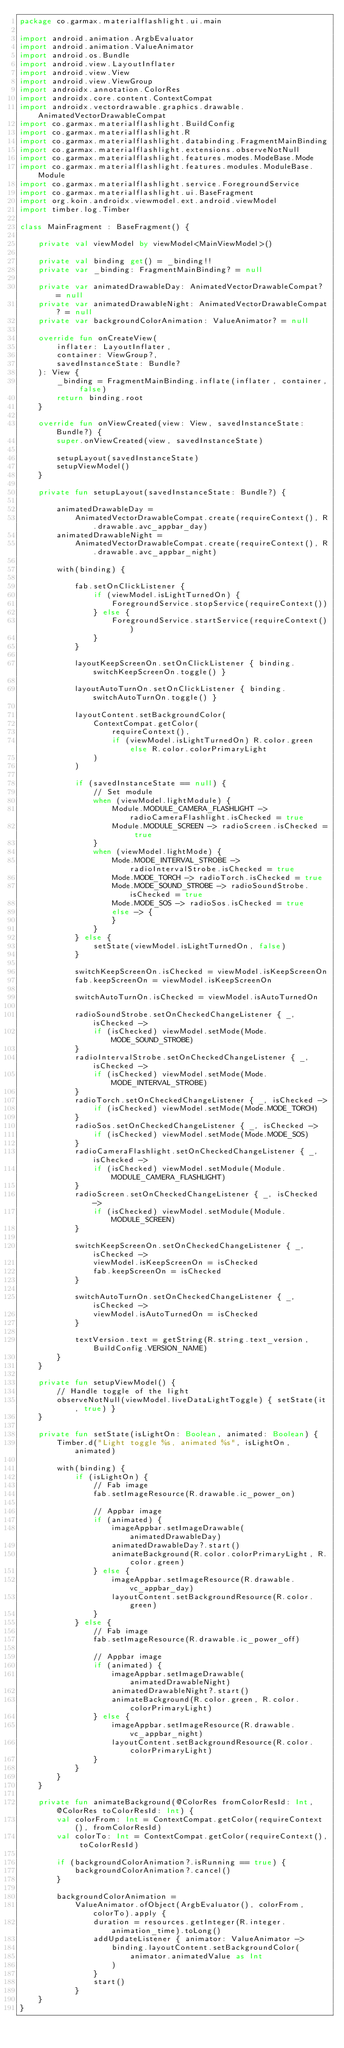<code> <loc_0><loc_0><loc_500><loc_500><_Kotlin_>package co.garmax.materialflashlight.ui.main

import android.animation.ArgbEvaluator
import android.animation.ValueAnimator
import android.os.Bundle
import android.view.LayoutInflater
import android.view.View
import android.view.ViewGroup
import androidx.annotation.ColorRes
import androidx.core.content.ContextCompat
import androidx.vectordrawable.graphics.drawable.AnimatedVectorDrawableCompat
import co.garmax.materialflashlight.BuildConfig
import co.garmax.materialflashlight.R
import co.garmax.materialflashlight.databinding.FragmentMainBinding
import co.garmax.materialflashlight.extensions.observeNotNull
import co.garmax.materialflashlight.features.modes.ModeBase.Mode
import co.garmax.materialflashlight.features.modules.ModuleBase.Module
import co.garmax.materialflashlight.service.ForegroundService
import co.garmax.materialflashlight.ui.BaseFragment
import org.koin.androidx.viewmodel.ext.android.viewModel
import timber.log.Timber

class MainFragment : BaseFragment() {

    private val viewModel by viewModel<MainViewModel>()

    private val binding get() = _binding!!
    private var _binding: FragmentMainBinding? = null

    private var animatedDrawableDay: AnimatedVectorDrawableCompat? = null
    private var animatedDrawableNight: AnimatedVectorDrawableCompat? = null
    private var backgroundColorAnimation: ValueAnimator? = null

    override fun onCreateView(
        inflater: LayoutInflater,
        container: ViewGroup?,
        savedInstanceState: Bundle?
    ): View {
        _binding = FragmentMainBinding.inflate(inflater, container, false)
        return binding.root
    }

    override fun onViewCreated(view: View, savedInstanceState: Bundle?) {
        super.onViewCreated(view, savedInstanceState)

        setupLayout(savedInstanceState)
        setupViewModel()
    }

    private fun setupLayout(savedInstanceState: Bundle?) {

        animatedDrawableDay =
            AnimatedVectorDrawableCompat.create(requireContext(), R.drawable.avc_appbar_day)
        animatedDrawableNight =
            AnimatedVectorDrawableCompat.create(requireContext(), R.drawable.avc_appbar_night)

        with(binding) {

            fab.setOnClickListener {
                if (viewModel.isLightTurnedOn) {
                    ForegroundService.stopService(requireContext())
                } else {
                    ForegroundService.startService(requireContext())
                }
            }

            layoutKeepScreenOn.setOnClickListener { binding.switchKeepScreenOn.toggle() }

            layoutAutoTurnOn.setOnClickListener { binding.switchAutoTurnOn.toggle() }

            layoutContent.setBackgroundColor(
                ContextCompat.getColor(
                    requireContext(),
                    if (viewModel.isLightTurnedOn) R.color.green else R.color.colorPrimaryLight
                )
            )

            if (savedInstanceState == null) {
                // Set module
                when (viewModel.lightModule) {
                    Module.MODULE_CAMERA_FLASHLIGHT -> radioCameraFlashlight.isChecked = true
                    Module.MODULE_SCREEN -> radioScreen.isChecked = true
                }
                when (viewModel.lightMode) {
                    Mode.MODE_INTERVAL_STROBE -> radioIntervalStrobe.isChecked = true
                    Mode.MODE_TORCH -> radioTorch.isChecked = true
                    Mode.MODE_SOUND_STROBE -> radioSoundStrobe.isChecked = true
                    Mode.MODE_SOS -> radioSos.isChecked = true
                    else -> {
                    }
                }
            } else {
                setState(viewModel.isLightTurnedOn, false)
            }

            switchKeepScreenOn.isChecked = viewModel.isKeepScreenOn
            fab.keepScreenOn = viewModel.isKeepScreenOn

            switchAutoTurnOn.isChecked = viewModel.isAutoTurnedOn

            radioSoundStrobe.setOnCheckedChangeListener { _, isChecked ->
                if (isChecked) viewModel.setMode(Mode.MODE_SOUND_STROBE)
            }
            radioIntervalStrobe.setOnCheckedChangeListener { _, isChecked ->
                if (isChecked) viewModel.setMode(Mode.MODE_INTERVAL_STROBE)
            }
            radioTorch.setOnCheckedChangeListener { _, isChecked ->
                if (isChecked) viewModel.setMode(Mode.MODE_TORCH)
            }
            radioSos.setOnCheckedChangeListener { _, isChecked ->
                if (isChecked) viewModel.setMode(Mode.MODE_SOS)
            }
            radioCameraFlashlight.setOnCheckedChangeListener { _, isChecked ->
                if (isChecked) viewModel.setModule(Module.MODULE_CAMERA_FLASHLIGHT)
            }
            radioScreen.setOnCheckedChangeListener { _, isChecked ->
                if (isChecked) viewModel.setModule(Module.MODULE_SCREEN)
            }

            switchKeepScreenOn.setOnCheckedChangeListener { _, isChecked ->
                viewModel.isKeepScreenOn = isChecked
                fab.keepScreenOn = isChecked
            }

            switchAutoTurnOn.setOnCheckedChangeListener { _, isChecked ->
                viewModel.isAutoTurnedOn = isChecked
            }

            textVersion.text = getString(R.string.text_version, BuildConfig.VERSION_NAME)
        }
    }

    private fun setupViewModel() {
        // Handle toggle of the light
        observeNotNull(viewModel.liveDataLightToggle) { setState(it, true) }
    }

    private fun setState(isLightOn: Boolean, animated: Boolean) {
        Timber.d("Light toggle %s, animated %s", isLightOn, animated)

        with(binding) {
            if (isLightOn) {
                // Fab image
                fab.setImageResource(R.drawable.ic_power_on)

                // Appbar image
                if (animated) {
                    imageAppbar.setImageDrawable(animatedDrawableDay)
                    animatedDrawableDay?.start()
                    animateBackground(R.color.colorPrimaryLight, R.color.green)
                } else {
                    imageAppbar.setImageResource(R.drawable.vc_appbar_day)
                    layoutContent.setBackgroundResource(R.color.green)
                }
            } else {
                // Fab image
                fab.setImageResource(R.drawable.ic_power_off)

                // Appbar image
                if (animated) {
                    imageAppbar.setImageDrawable(animatedDrawableNight)
                    animatedDrawableNight?.start()
                    animateBackground(R.color.green, R.color.colorPrimaryLight)
                } else {
                    imageAppbar.setImageResource(R.drawable.vc_appbar_night)
                    layoutContent.setBackgroundResource(R.color.colorPrimaryLight)
                }
            }
        }
    }

    private fun animateBackground(@ColorRes fromColorResId: Int, @ColorRes toColorResId: Int) {
        val colorFrom: Int = ContextCompat.getColor(requireContext(), fromColorResId)
        val colorTo: Int = ContextCompat.getColor(requireContext(), toColorResId)

        if (backgroundColorAnimation?.isRunning == true) {
            backgroundColorAnimation?.cancel()
        }

        backgroundColorAnimation =
            ValueAnimator.ofObject(ArgbEvaluator(), colorFrom, colorTo).apply {
                duration = resources.getInteger(R.integer.animation_time).toLong()
                addUpdateListener { animator: ValueAnimator ->
                    binding.layoutContent.setBackgroundColor(
                        animator.animatedValue as Int
                    )
                }
                start()
            }
    }
}</code> 